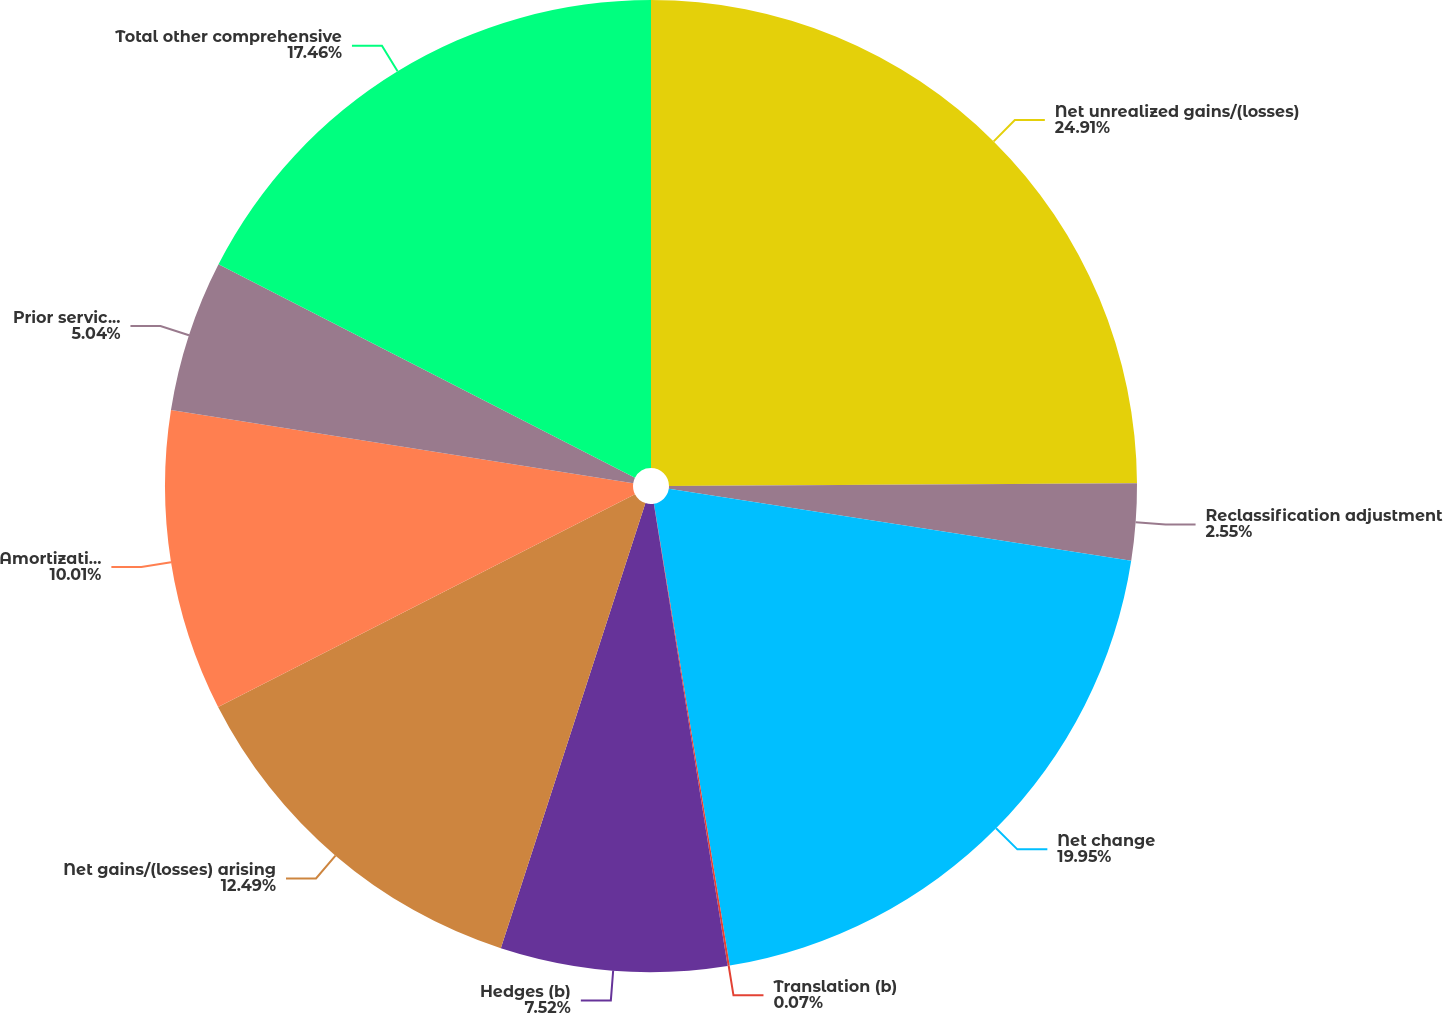Convert chart. <chart><loc_0><loc_0><loc_500><loc_500><pie_chart><fcel>Net unrealized gains/(losses)<fcel>Reclassification adjustment<fcel>Net change<fcel>Translation (b)<fcel>Hedges (b)<fcel>Net gains/(losses) arising<fcel>Amortization of net loss<fcel>Prior service costs/(credits)<fcel>Total other comprehensive<nl><fcel>24.91%<fcel>2.55%<fcel>19.95%<fcel>0.07%<fcel>7.52%<fcel>12.49%<fcel>10.01%<fcel>5.04%<fcel>17.46%<nl></chart> 